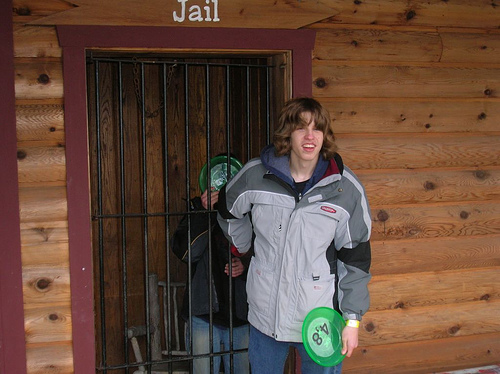Read and extract the text from this image. Jail 4 8 